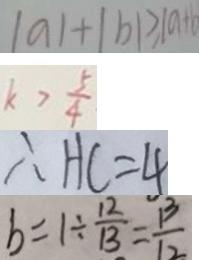Convert formula to latex. <formula><loc_0><loc_0><loc_500><loc_500>\vert a \vert + \vert b \vert > \vert a + b 
 k > \frac { 5 } { 4 } 
 \therefore H C = 4 
 b = 1 \div \frac { 1 2 } { 1 3 } = \frac { 1 3 } { 1 2 }</formula> 